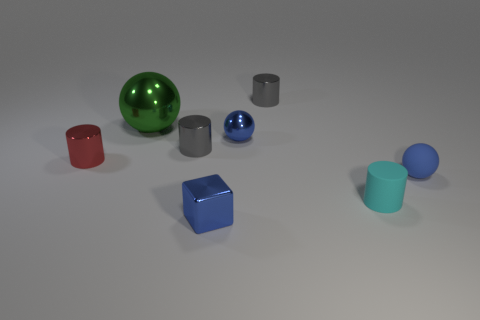Is there any other thing that is the same size as the green sphere?
Provide a succinct answer. No. Is the red object made of the same material as the big sphere that is right of the small red shiny thing?
Your answer should be very brief. Yes. There is a tiny block in front of the red metallic cylinder; what material is it?
Offer a terse response. Metal. How big is the green metallic ball?
Give a very brief answer. Large. There is a rubber object to the left of the tiny blue rubber sphere; is it the same size as the blue sphere that is on the left side of the small matte cylinder?
Offer a terse response. Yes. What is the size of the red object that is the same shape as the cyan object?
Ensure brevity in your answer.  Small. There is a red object; is it the same size as the gray object that is left of the tiny blue metallic cube?
Your answer should be compact. Yes. Is there a tiny gray object that is behind the shiny sphere to the left of the metal block?
Keep it short and to the point. Yes. What shape is the gray object that is left of the small metallic cube?
Keep it short and to the point. Cylinder. What is the material of the cube that is the same color as the tiny matte ball?
Your answer should be compact. Metal. 